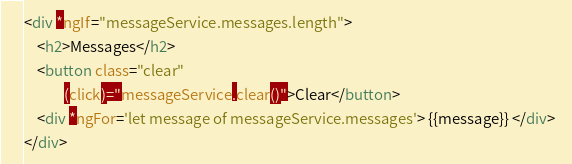<code> <loc_0><loc_0><loc_500><loc_500><_HTML_><div *ngIf="messageService.messages.length">
    <h2>Messages</h2>
    <button class="clear"
            (click)="messageService.clear()">Clear</button>
    <div *ngFor='let message of messageService.messages'> {{message}} </div>  
</div></code> 